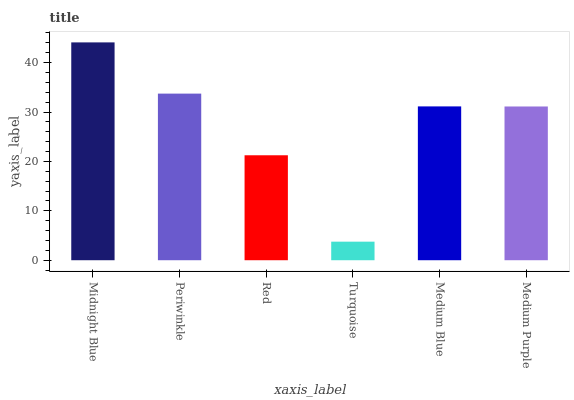Is Periwinkle the minimum?
Answer yes or no. No. Is Periwinkle the maximum?
Answer yes or no. No. Is Midnight Blue greater than Periwinkle?
Answer yes or no. Yes. Is Periwinkle less than Midnight Blue?
Answer yes or no. Yes. Is Periwinkle greater than Midnight Blue?
Answer yes or no. No. Is Midnight Blue less than Periwinkle?
Answer yes or no. No. Is Medium Blue the high median?
Answer yes or no. Yes. Is Medium Purple the low median?
Answer yes or no. Yes. Is Periwinkle the high median?
Answer yes or no. No. Is Periwinkle the low median?
Answer yes or no. No. 